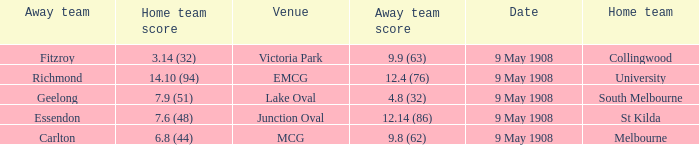Name the home team for carlton away team Melbourne. 